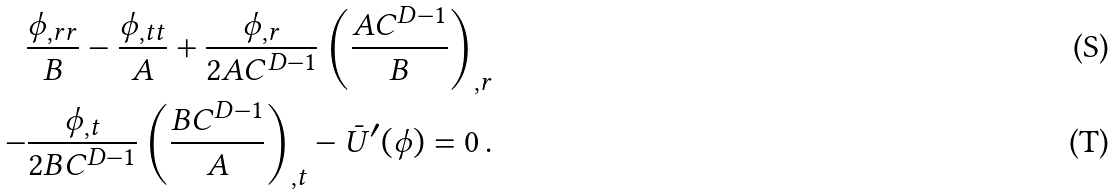<formula> <loc_0><loc_0><loc_500><loc_500>\frac { \phi _ { , r r } } { B } - \frac { \phi _ { , t t } } { A } + \frac { \phi _ { , r } } { 2 A C ^ { D - 1 } } \left ( \frac { A C ^ { D - 1 } } { B } \right ) _ { , r } \\ - \frac { \phi _ { , t } } { 2 B C ^ { D - 1 } } \left ( \frac { B C ^ { D - 1 } } { A } \right ) _ { , t } - \bar { U } ^ { \prime } ( \phi ) = 0 \, .</formula> 